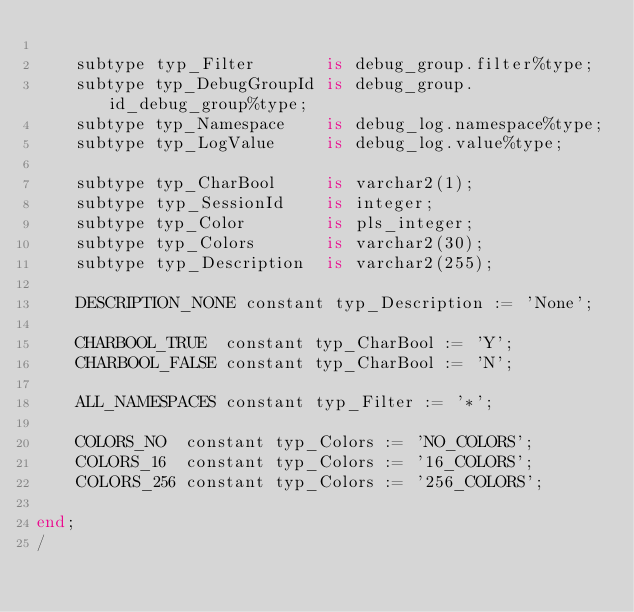Convert code to text. <code><loc_0><loc_0><loc_500><loc_500><_SQL_>
    subtype typ_Filter       is debug_group.filter%type;
    subtype typ_DebugGroupId is debug_group.id_debug_group%type;
    subtype typ_Namespace    is debug_log.namespace%type;
    subtype typ_LogValue     is debug_log.value%type;

    subtype typ_CharBool     is varchar2(1);
    subtype typ_SessionId    is integer;
    subtype typ_Color        is pls_integer;
    subtype typ_Colors       is varchar2(30);
    subtype typ_Description  is varchar2(255);

    DESCRIPTION_NONE constant typ_Description := 'None';

    CHARBOOL_TRUE  constant typ_CharBool := 'Y';
    CHARBOOL_FALSE constant typ_CharBool := 'N';

    ALL_NAMESPACES constant typ_Filter := '*';

    COLORS_NO  constant typ_Colors := 'NO_COLORS';
    COLORS_16  constant typ_Colors := '16_COLORS';
    COLORS_256 constant typ_Colors := '256_COLORS';

end;
/</code> 